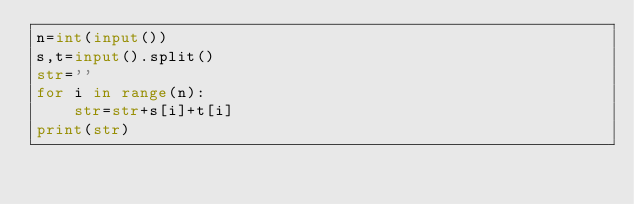Convert code to text. <code><loc_0><loc_0><loc_500><loc_500><_Python_>n=int(input())
s,t=input().split()
str=''
for i in range(n):
    str=str+s[i]+t[i]
print(str)</code> 